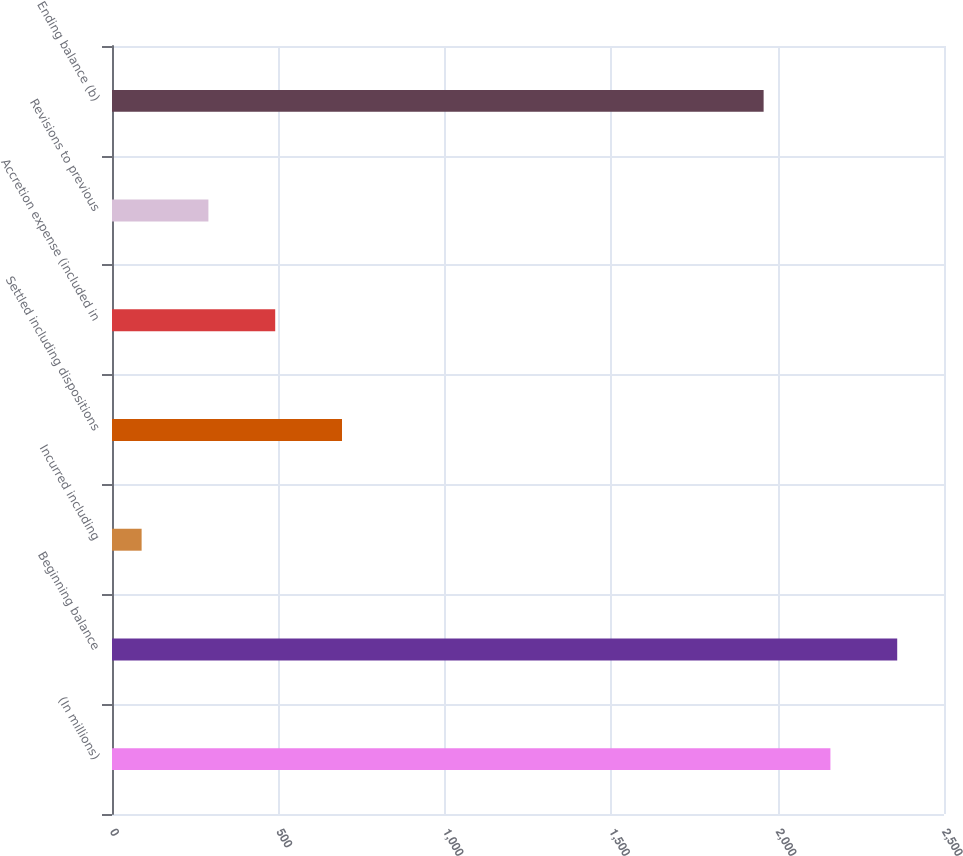Convert chart. <chart><loc_0><loc_0><loc_500><loc_500><bar_chart><fcel>(In millions)<fcel>Beginning balance<fcel>Incurred including<fcel>Settled including dispositions<fcel>Accretion expense (included in<fcel>Revisions to previous<fcel>Ending balance (b)<nl><fcel>2158.7<fcel>2359.4<fcel>89<fcel>691.1<fcel>490.4<fcel>289.7<fcel>1958<nl></chart> 